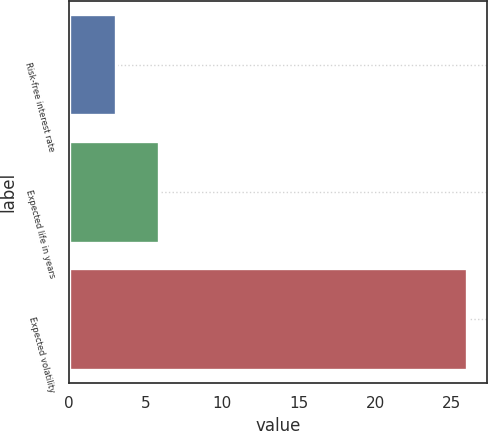Convert chart. <chart><loc_0><loc_0><loc_500><loc_500><bar_chart><fcel>Risk-free interest rate<fcel>Expected life in years<fcel>Expected volatility<nl><fcel>3.09<fcel>5.9<fcel>26<nl></chart> 